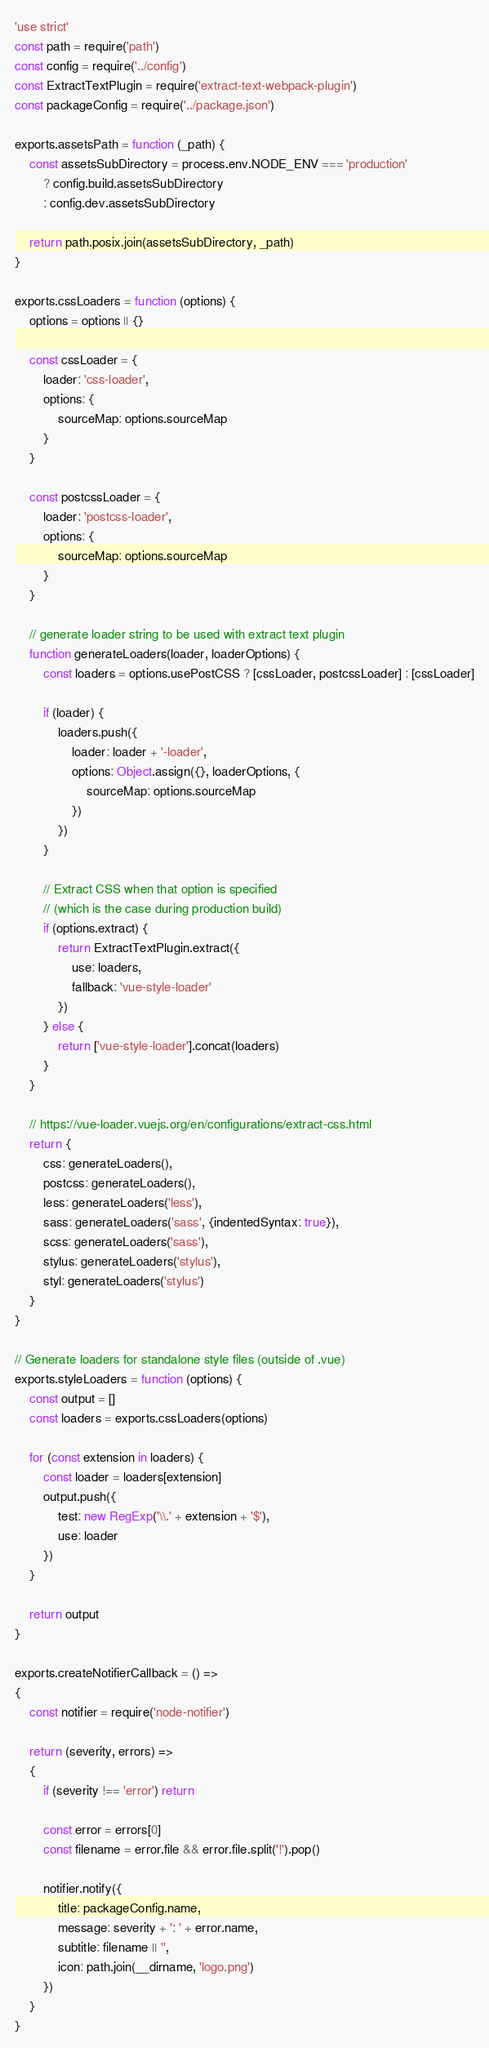Convert code to text. <code><loc_0><loc_0><loc_500><loc_500><_JavaScript_>'use strict'
const path = require('path')
const config = require('../config')
const ExtractTextPlugin = require('extract-text-webpack-plugin')
const packageConfig = require('../package.json')

exports.assetsPath = function (_path) {
    const assetsSubDirectory = process.env.NODE_ENV === 'production'
        ? config.build.assetsSubDirectory
        : config.dev.assetsSubDirectory

    return path.posix.join(assetsSubDirectory, _path)
}

exports.cssLoaders = function (options) {
    options = options || {}

    const cssLoader = {
        loader: 'css-loader',
        options: {
            sourceMap: options.sourceMap
        }
    }

    const postcssLoader = {
        loader: 'postcss-loader',
        options: {
            sourceMap: options.sourceMap
        }
    }

    // generate loader string to be used with extract text plugin
    function generateLoaders(loader, loaderOptions) {
        const loaders = options.usePostCSS ? [cssLoader, postcssLoader] : [cssLoader]

        if (loader) {
            loaders.push({
                loader: loader + '-loader',
                options: Object.assign({}, loaderOptions, {
                    sourceMap: options.sourceMap
                })
            })
        }

        // Extract CSS when that option is specified
        // (which is the case during production build)
        if (options.extract) {
            return ExtractTextPlugin.extract({
                use: loaders,
                fallback: 'vue-style-loader'
            })
        } else {
            return ['vue-style-loader'].concat(loaders)
        }
    }

    // https://vue-loader.vuejs.org/en/configurations/extract-css.html
    return {
        css: generateLoaders(),
        postcss: generateLoaders(),
        less: generateLoaders('less'),
        sass: generateLoaders('sass', {indentedSyntax: true}),
        scss: generateLoaders('sass'),
        stylus: generateLoaders('stylus'),
        styl: generateLoaders('stylus')
    }
}

// Generate loaders for standalone style files (outside of .vue)
exports.styleLoaders = function (options) {
    const output = []
    const loaders = exports.cssLoaders(options)

    for (const extension in loaders) {
        const loader = loaders[extension]
        output.push({
            test: new RegExp('\\.' + extension + '$'),
            use: loader
        })
    }

    return output
}

exports.createNotifierCallback = () =>
{
    const notifier = require('node-notifier')

    return (severity, errors) =>
    {
        if (severity !== 'error') return

        const error = errors[0]
        const filename = error.file && error.file.split('!').pop()

        notifier.notify({
            title: packageConfig.name,
            message: severity + ': ' + error.name,
            subtitle: filename || '',
            icon: path.join(__dirname, 'logo.png')
        })
    }
}
</code> 